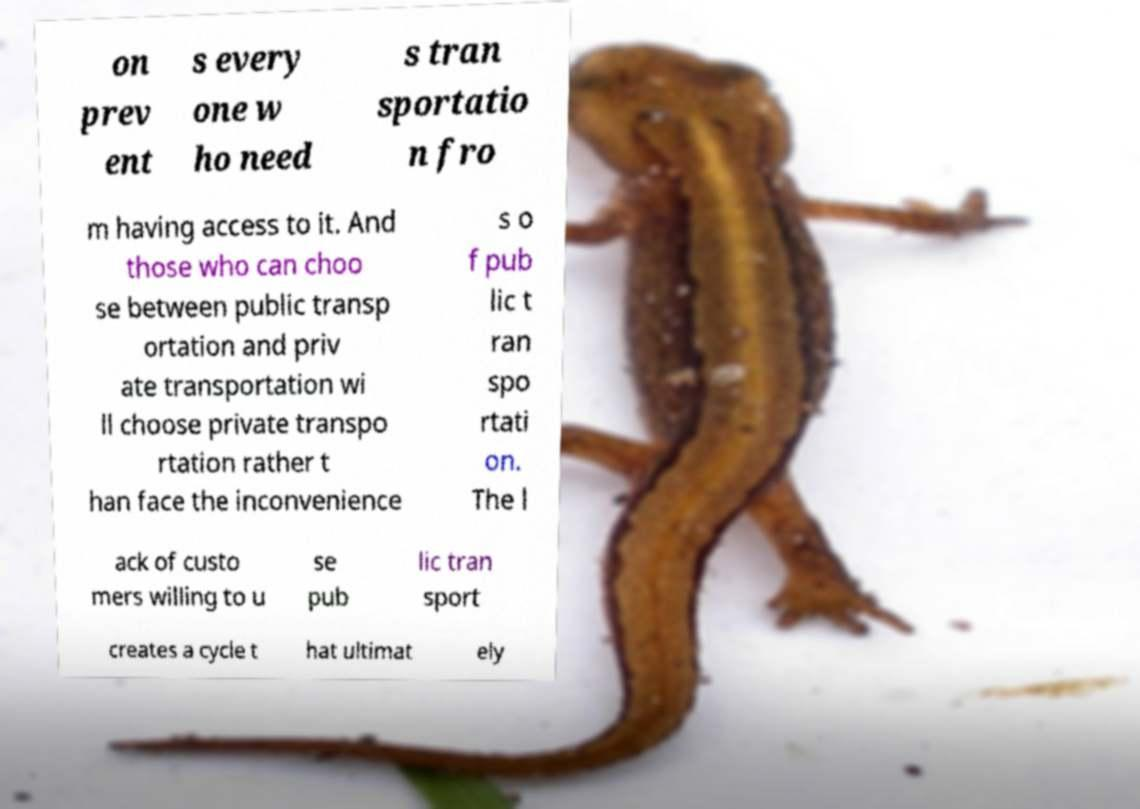For documentation purposes, I need the text within this image transcribed. Could you provide that? on prev ent s every one w ho need s tran sportatio n fro m having access to it. And those who can choo se between public transp ortation and priv ate transportation wi ll choose private transpo rtation rather t han face the inconvenience s o f pub lic t ran spo rtati on. The l ack of custo mers willing to u se pub lic tran sport creates a cycle t hat ultimat ely 